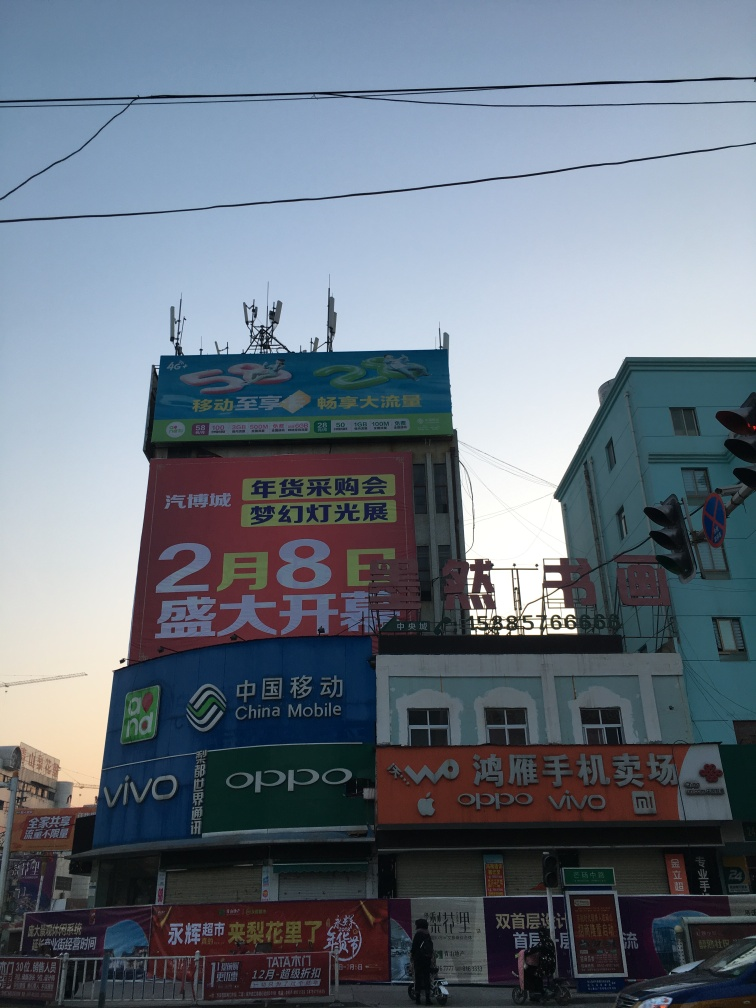Is the quality of this picture good? The picture is of decent quality with good daylight illumination. All text and signage are legible, and there's minimal noise or blur. However, it could be improved by ensuring a straight horizon line and avoiding the power lines at the top, which can be distracting. 